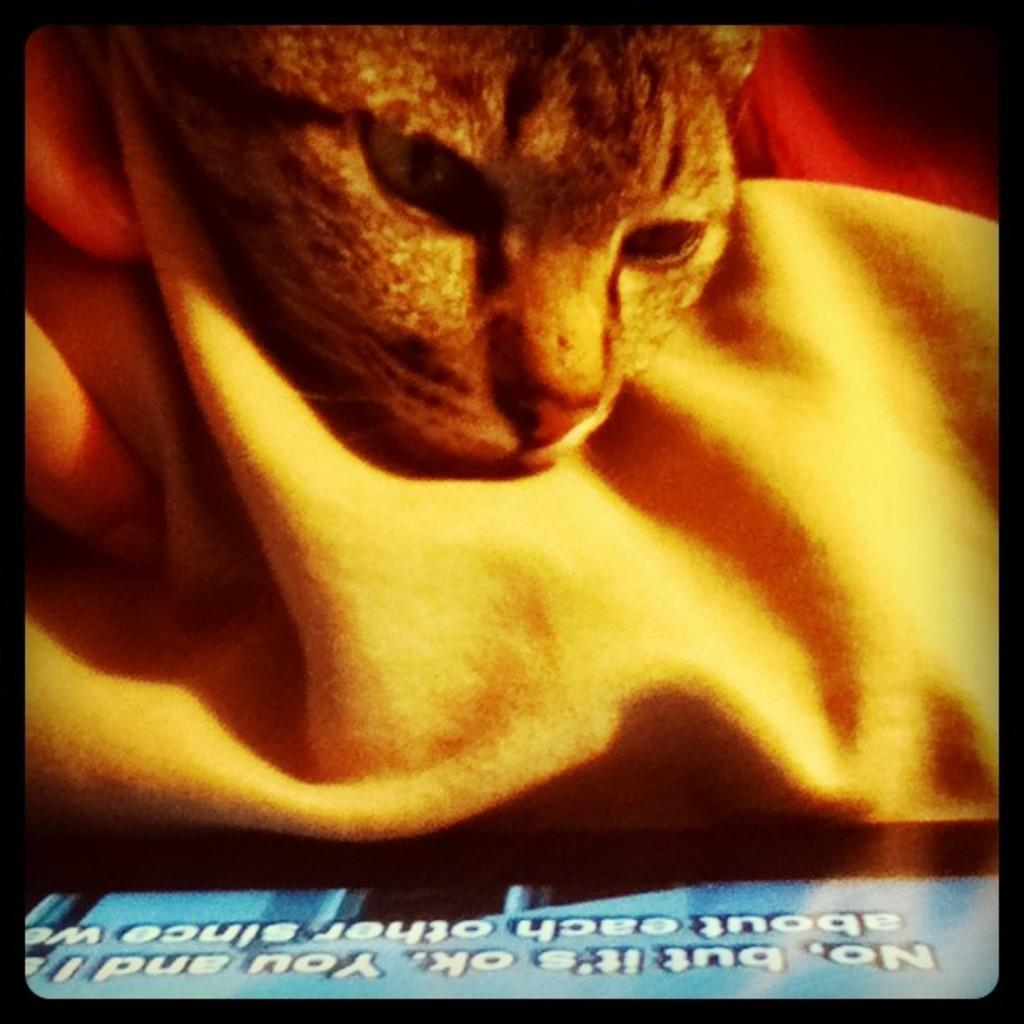What is the main object in the image? There is a screen in the image. What can be seen on the screen? A cat is visible on the screen, along with cloth and text. Can you describe the text at the bottom of the screen? Unfortunately, the specific text cannot be determined from the provided facts. How many silver coins can be seen on the screen? There is no mention of silver coins in the image, so it cannot be determined how many are present. 